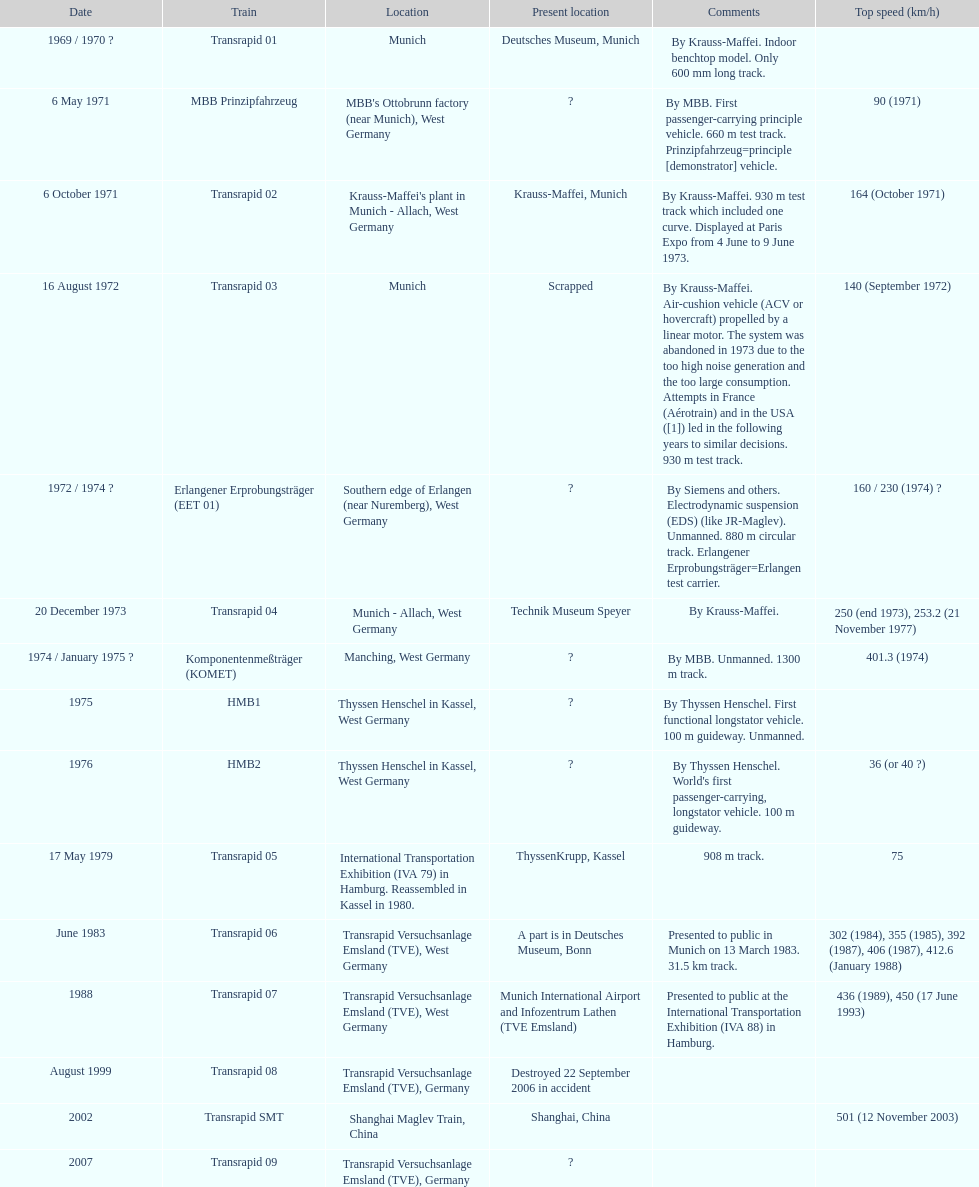What is the only train to reach a top speed of 500 or more? Transrapid SMT. 